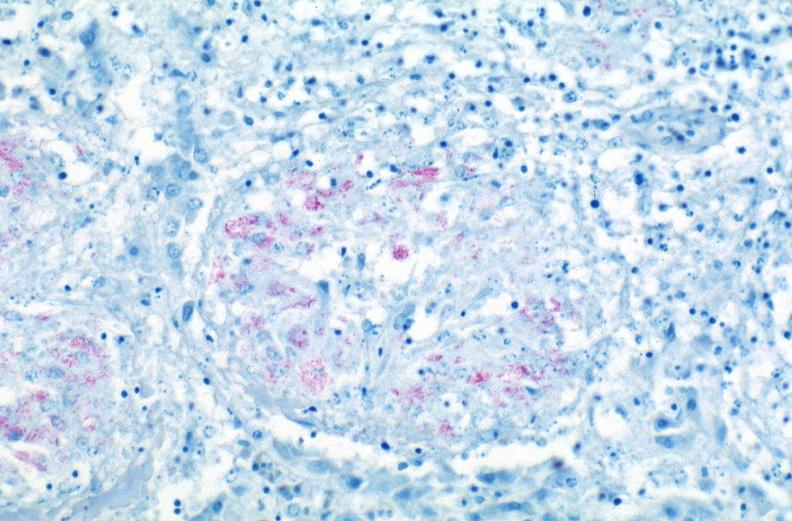does this image show lung, mycobacterium tuberculosis, acid fast?
Answer the question using a single word or phrase. Yes 